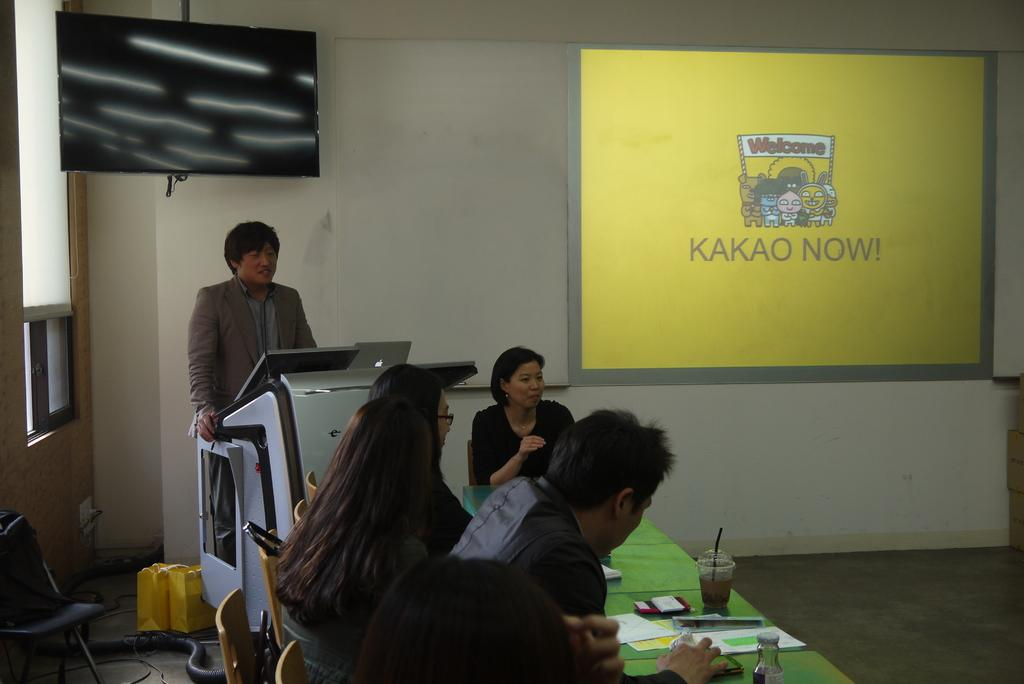<image>
Offer a succinct explanation of the picture presented. people at a table and guy in suit giving speech and yellow display for kakao now on wall 